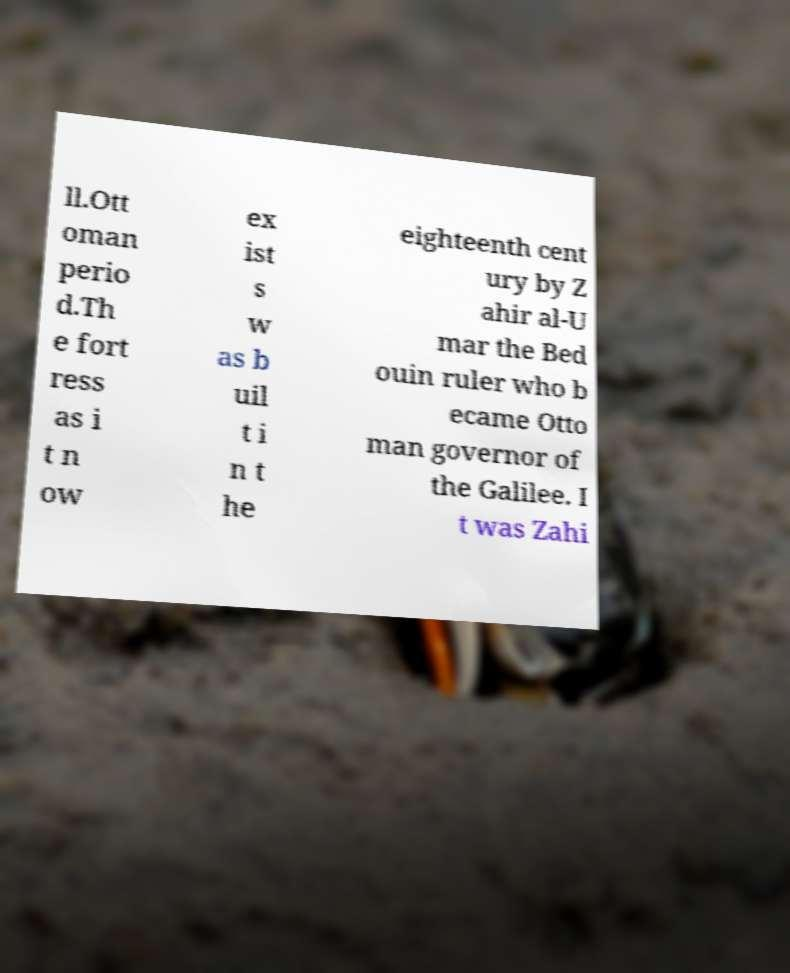Can you read and provide the text displayed in the image?This photo seems to have some interesting text. Can you extract and type it out for me? ll.Ott oman perio d.Th e fort ress as i t n ow ex ist s w as b uil t i n t he eighteenth cent ury by Z ahir al-U mar the Bed ouin ruler who b ecame Otto man governor of the Galilee. I t was Zahi 